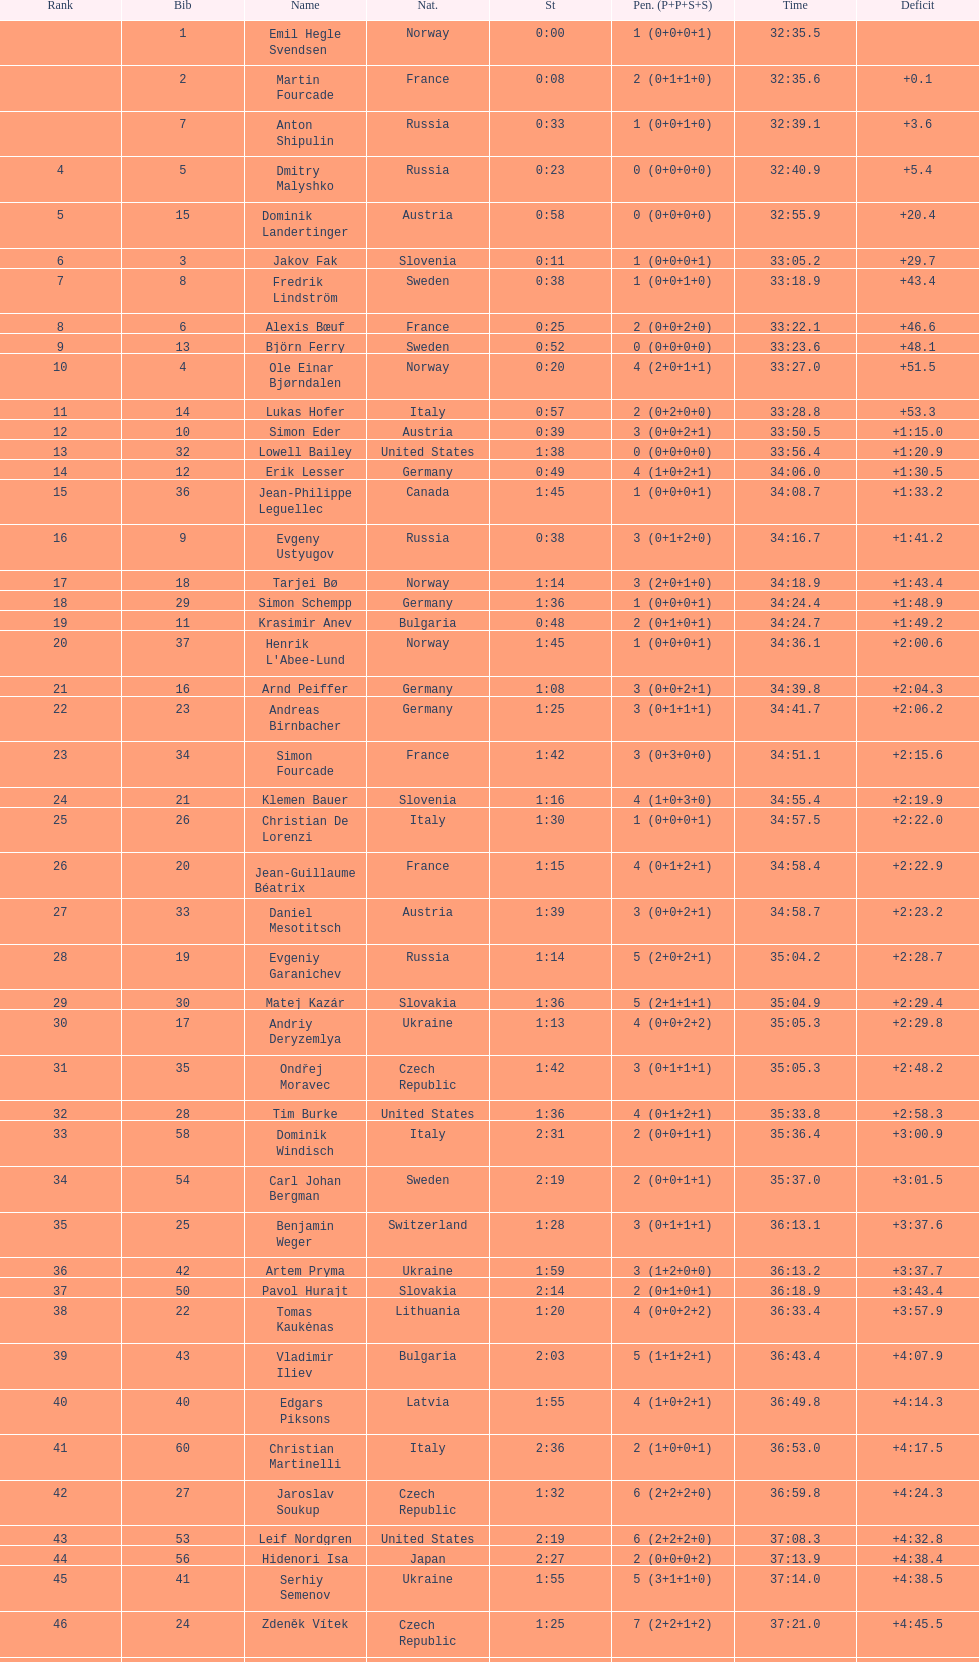What were the total number of "ties" (people who finished with the exact same time?) 2. 